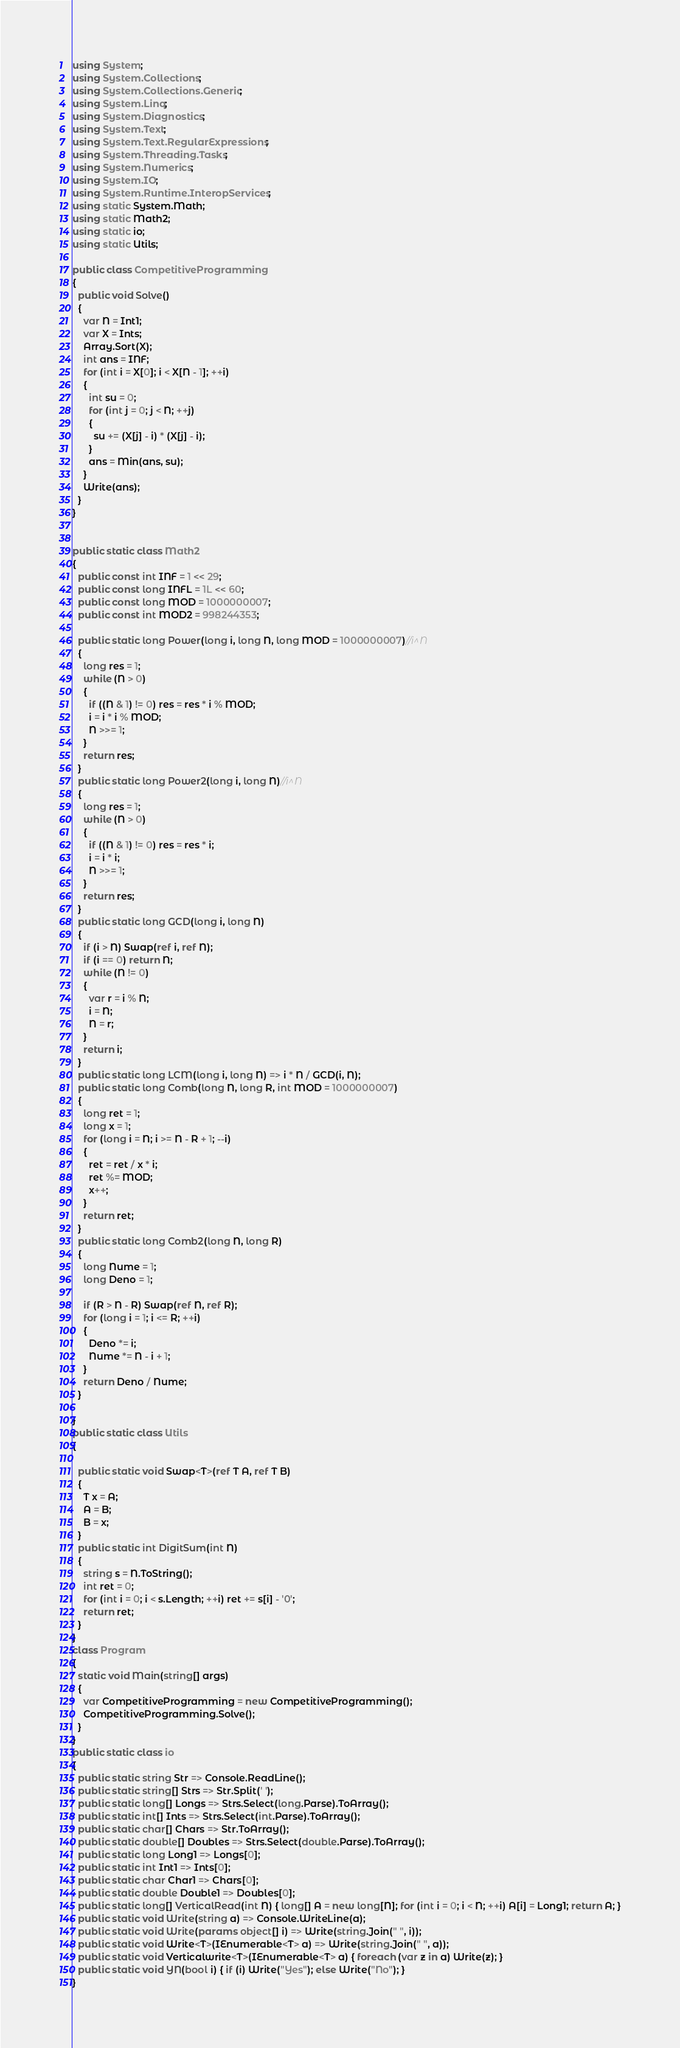Convert code to text. <code><loc_0><loc_0><loc_500><loc_500><_C#_>using System;
using System.Collections;
using System.Collections.Generic;
using System.Linq;
using System.Diagnostics;
using System.Text;
using System.Text.RegularExpressions;
using System.Threading.Tasks;
using System.Numerics;
using System.IO;
using System.Runtime.InteropServices;
using static System.Math;
using static Math2;
using static io;
using static Utils;

public class CompetitiveProgramming
{
  public void Solve()
  {
    var N = Int1;
    var X = Ints;
    Array.Sort(X);
    int ans = INF;
    for (int i = X[0]; i < X[N - 1]; ++i)
    {
      int su = 0;
      for (int j = 0; j < N; ++j)
      {
        su += (X[j] - i) * (X[j] - i);
      }
      ans = Min(ans, su);
    }
    Write(ans);
  }
}


public static class Math2
{
  public const int INF = 1 << 29;
  public const long INFL = 1L << 60;
  public const long MOD = 1000000007;
  public const int MOD2 = 998244353;

  public static long Power(long i, long N, long MOD = 1000000007)//i^N
  {
    long res = 1;
    while (N > 0)
    {
      if ((N & 1) != 0) res = res * i % MOD;
      i = i * i % MOD;
      N >>= 1;
    }
    return res;
  }
  public static long Power2(long i, long N)//i^N
  {
    long res = 1;
    while (N > 0)
    {
      if ((N & 1) != 0) res = res * i;
      i = i * i;
      N >>= 1;
    }
    return res;
  }
  public static long GCD(long i, long N)
  {
    if (i > N) Swap(ref i, ref N);
    if (i == 0) return N;
    while (N != 0)
    {
      var r = i % N;
      i = N;
      N = r;
    }
    return i;
  }
  public static long LCM(long i, long N) => i * N / GCD(i, N);
  public static long Comb(long N, long R, int MOD = 1000000007)
  {
    long ret = 1;
    long x = 1;
    for (long i = N; i >= N - R + 1; --i)
    {
      ret = ret / x * i;
      ret %= MOD;
      x++;
    }
    return ret;
  }
  public static long Comb2(long N, long R)
  {
    long Nume = 1;
    long Deno = 1;

    if (R > N - R) Swap(ref N, ref R);
    for (long i = 1; i <= R; ++i)
    {
      Deno *= i;
      Nume *= N - i + 1;
    }
    return Deno / Nume;
  }

}
public static class Utils
{

  public static void Swap<T>(ref T A, ref T B)
  {
    T x = A;
    A = B;
    B = x;
  }
  public static int DigitSum(int N)
  {
    string s = N.ToString();
    int ret = 0;
    for (int i = 0; i < s.Length; ++i) ret += s[i] - '0';
    return ret;
  }
}
class Program
{
  static void Main(string[] args)
  {
    var CompetitiveProgramming = new CompetitiveProgramming();
    CompetitiveProgramming.Solve();
  }
}
public static class io
{
  public static string Str => Console.ReadLine();
  public static string[] Strs => Str.Split(' ');
  public static long[] Longs => Strs.Select(long.Parse).ToArray();
  public static int[] Ints => Strs.Select(int.Parse).ToArray();
  public static char[] Chars => Str.ToArray();
  public static double[] Doubles => Strs.Select(double.Parse).ToArray();
  public static long Long1 => Longs[0];
  public static int Int1 => Ints[0];
  public static char Char1 => Chars[0];
  public static double Double1 => Doubles[0];
  public static long[] VerticalRead(int N) { long[] A = new long[N]; for (int i = 0; i < N; ++i) A[i] = Long1; return A; }
  public static void Write(string a) => Console.WriteLine(a);
  public static void Write(params object[] i) => Write(string.Join(" ", i));
  public static void Write<T>(IEnumerable<T> a) => Write(string.Join(" ", a));
  public static void Verticalwrite<T>(IEnumerable<T> a) { foreach (var z in a) Write(z); }
  public static void YN(bool i) { if (i) Write("Yes"); else Write("No"); }
}
</code> 